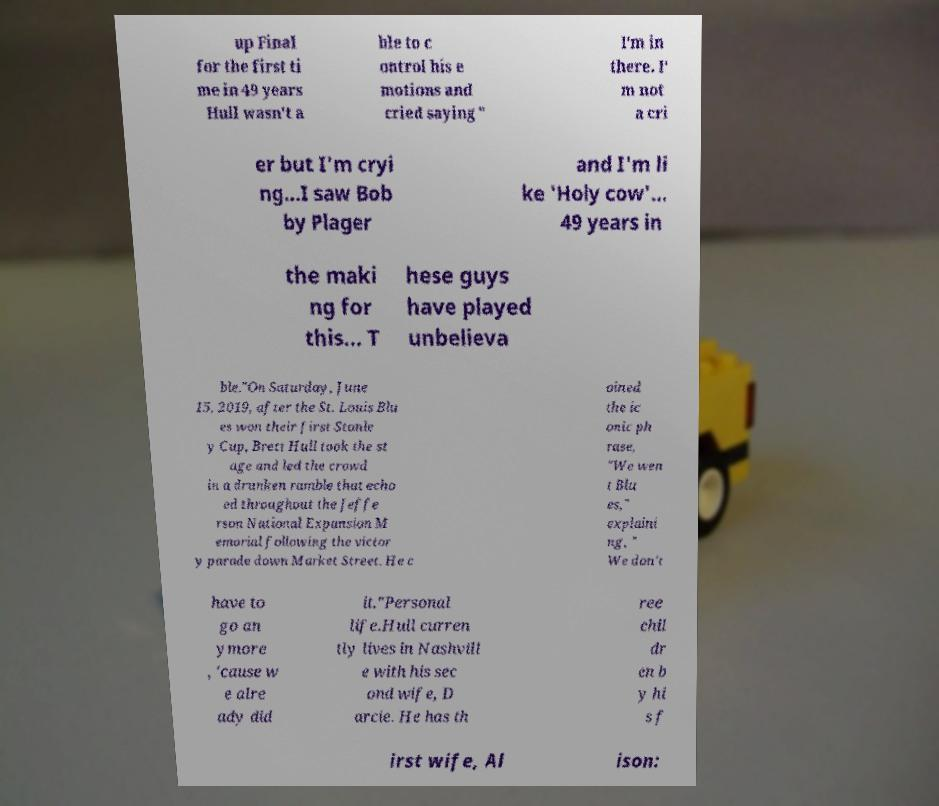For documentation purposes, I need the text within this image transcribed. Could you provide that? up Final for the first ti me in 49 years Hull wasn't a ble to c ontrol his e motions and cried saying " I'm in there. I' m not a cri er but I'm cryi ng...I saw Bob by Plager and I'm li ke 'Holy cow'... 49 years in the maki ng for this... T hese guys have played unbelieva ble."On Saturday, June 15, 2019, after the St. Louis Blu es won their first Stanle y Cup, Brett Hull took the st age and led the crowd in a drunken ramble that echo ed throughout the Jeffe rson National Expansion M emorial following the victor y parade down Market Street. He c oined the ic onic ph rase, "We wen t Blu es," explaini ng, " We don't have to go an ymore , 'cause w e alre ady did it."Personal life.Hull curren tly lives in Nashvill e with his sec ond wife, D arcie. He has th ree chil dr en b y hi s f irst wife, Al ison: 